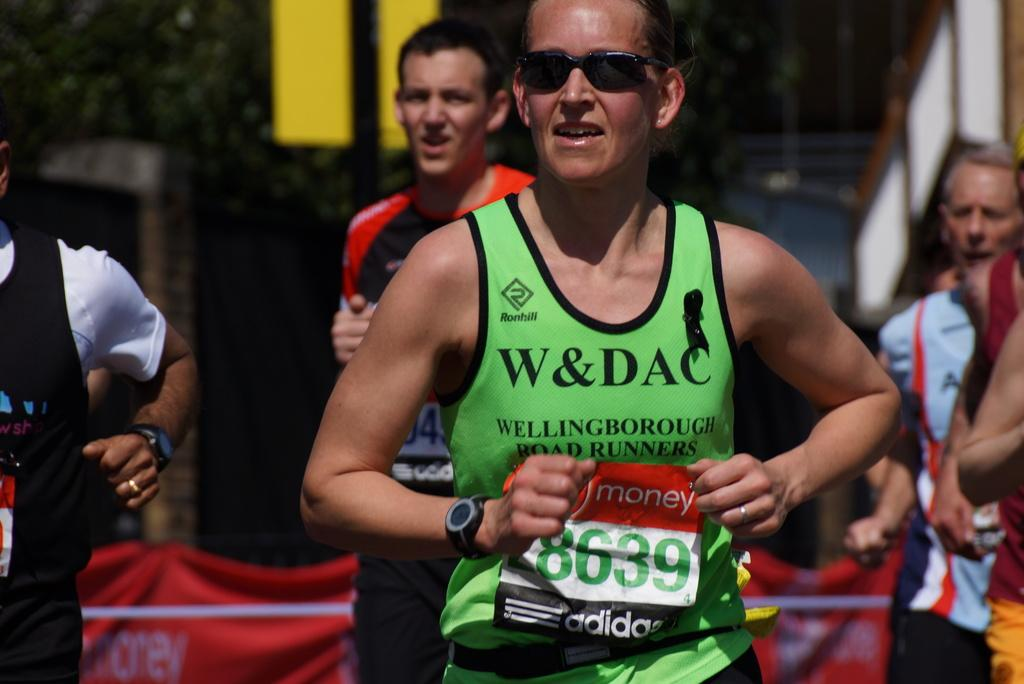<image>
Summarize the visual content of the image. A runner with a shirt that says W&DAC is running a marathon. 